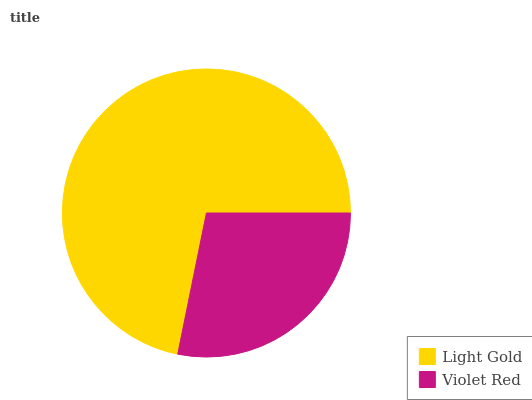Is Violet Red the minimum?
Answer yes or no. Yes. Is Light Gold the maximum?
Answer yes or no. Yes. Is Violet Red the maximum?
Answer yes or no. No. Is Light Gold greater than Violet Red?
Answer yes or no. Yes. Is Violet Red less than Light Gold?
Answer yes or no. Yes. Is Violet Red greater than Light Gold?
Answer yes or no. No. Is Light Gold less than Violet Red?
Answer yes or no. No. Is Light Gold the high median?
Answer yes or no. Yes. Is Violet Red the low median?
Answer yes or no. Yes. Is Violet Red the high median?
Answer yes or no. No. Is Light Gold the low median?
Answer yes or no. No. 